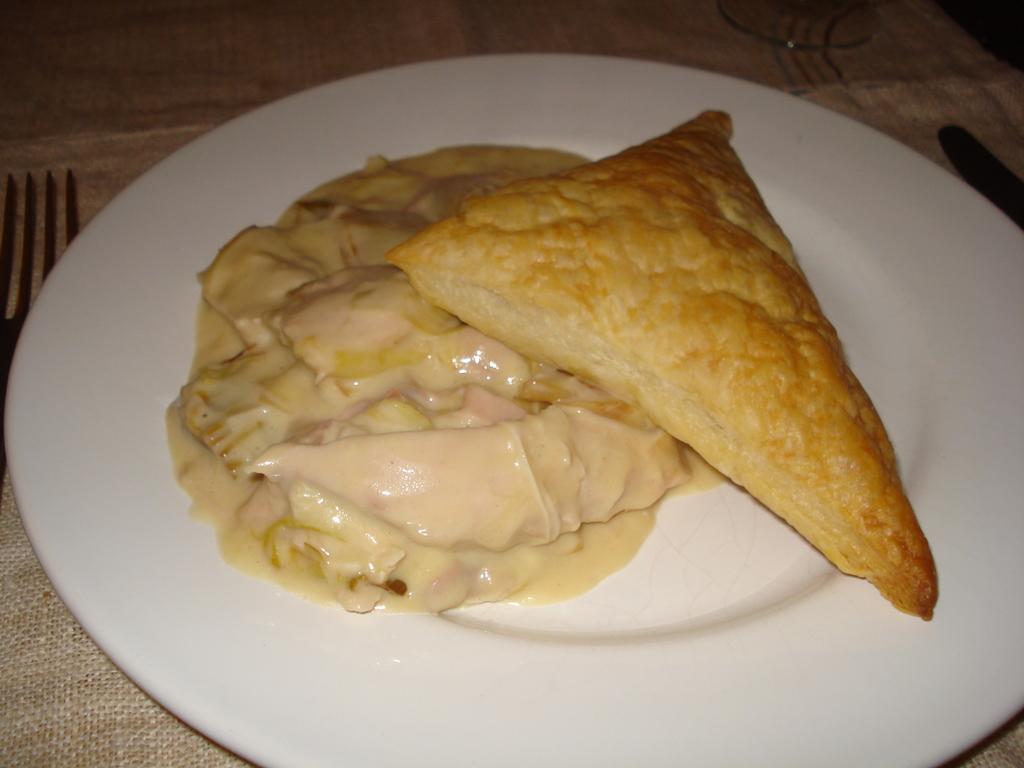In one or two sentences, can you explain what this image depicts? On the table there is a plate, fork, cloth, and food. 